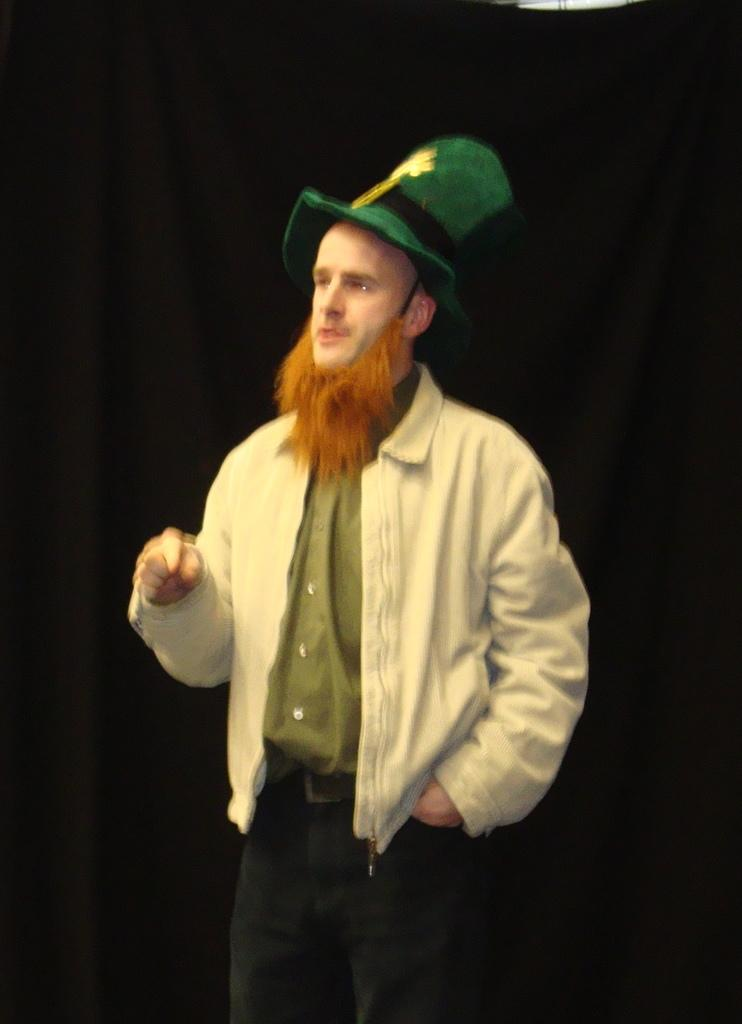Who is the main subject in the image? There is a man in the center of the image. What can be observed about the man's facial hair? The man has a beard. What color is the hat the man is wearing? The man is wearing a green color hat. What is the man's posture in the image? The man is standing. What color is the background of the image? The background of the image is black. Can you tell me how many keys the queen is holding in the image? There is no queen or keys present in the image; it features a man with a beard and a green hat. Is the man swimming in the image? No, the man is not swimming in the image; he is standing. 